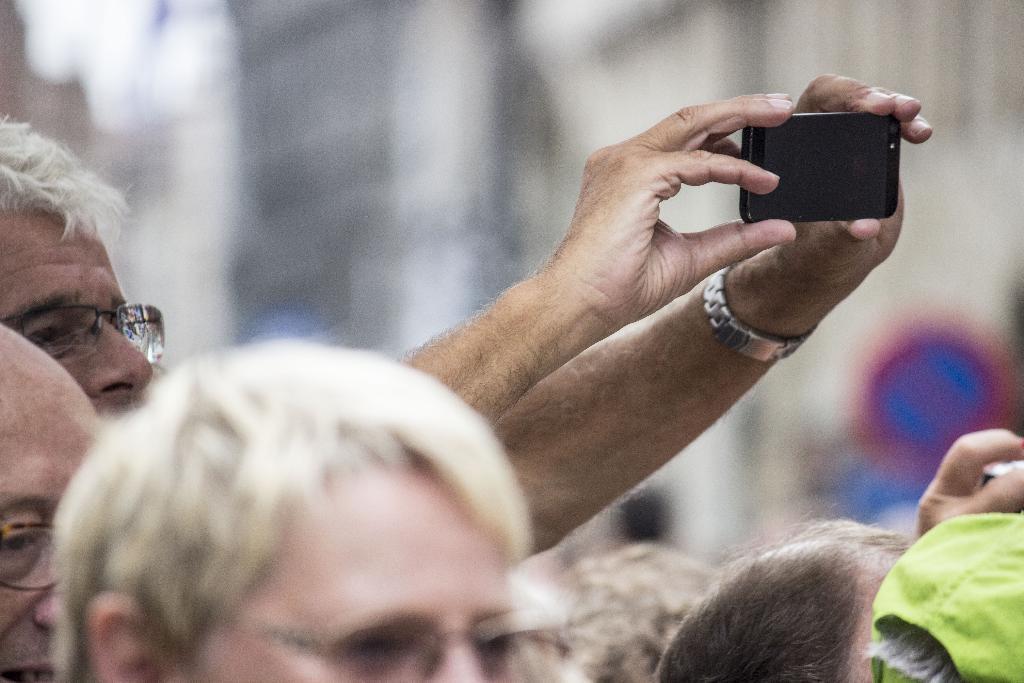How would you summarize this image in a sentence or two? There is a old man holding a phone in his hands, taking a picture with it. He's wearing a watch and there are some people in the picture. 